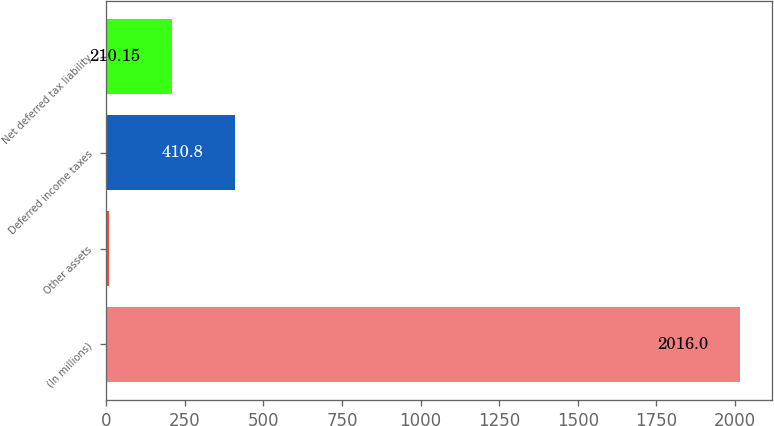Convert chart to OTSL. <chart><loc_0><loc_0><loc_500><loc_500><bar_chart><fcel>(In millions)<fcel>Other assets<fcel>Deferred income taxes<fcel>Net deferred tax liability<nl><fcel>2016<fcel>9.5<fcel>410.8<fcel>210.15<nl></chart> 